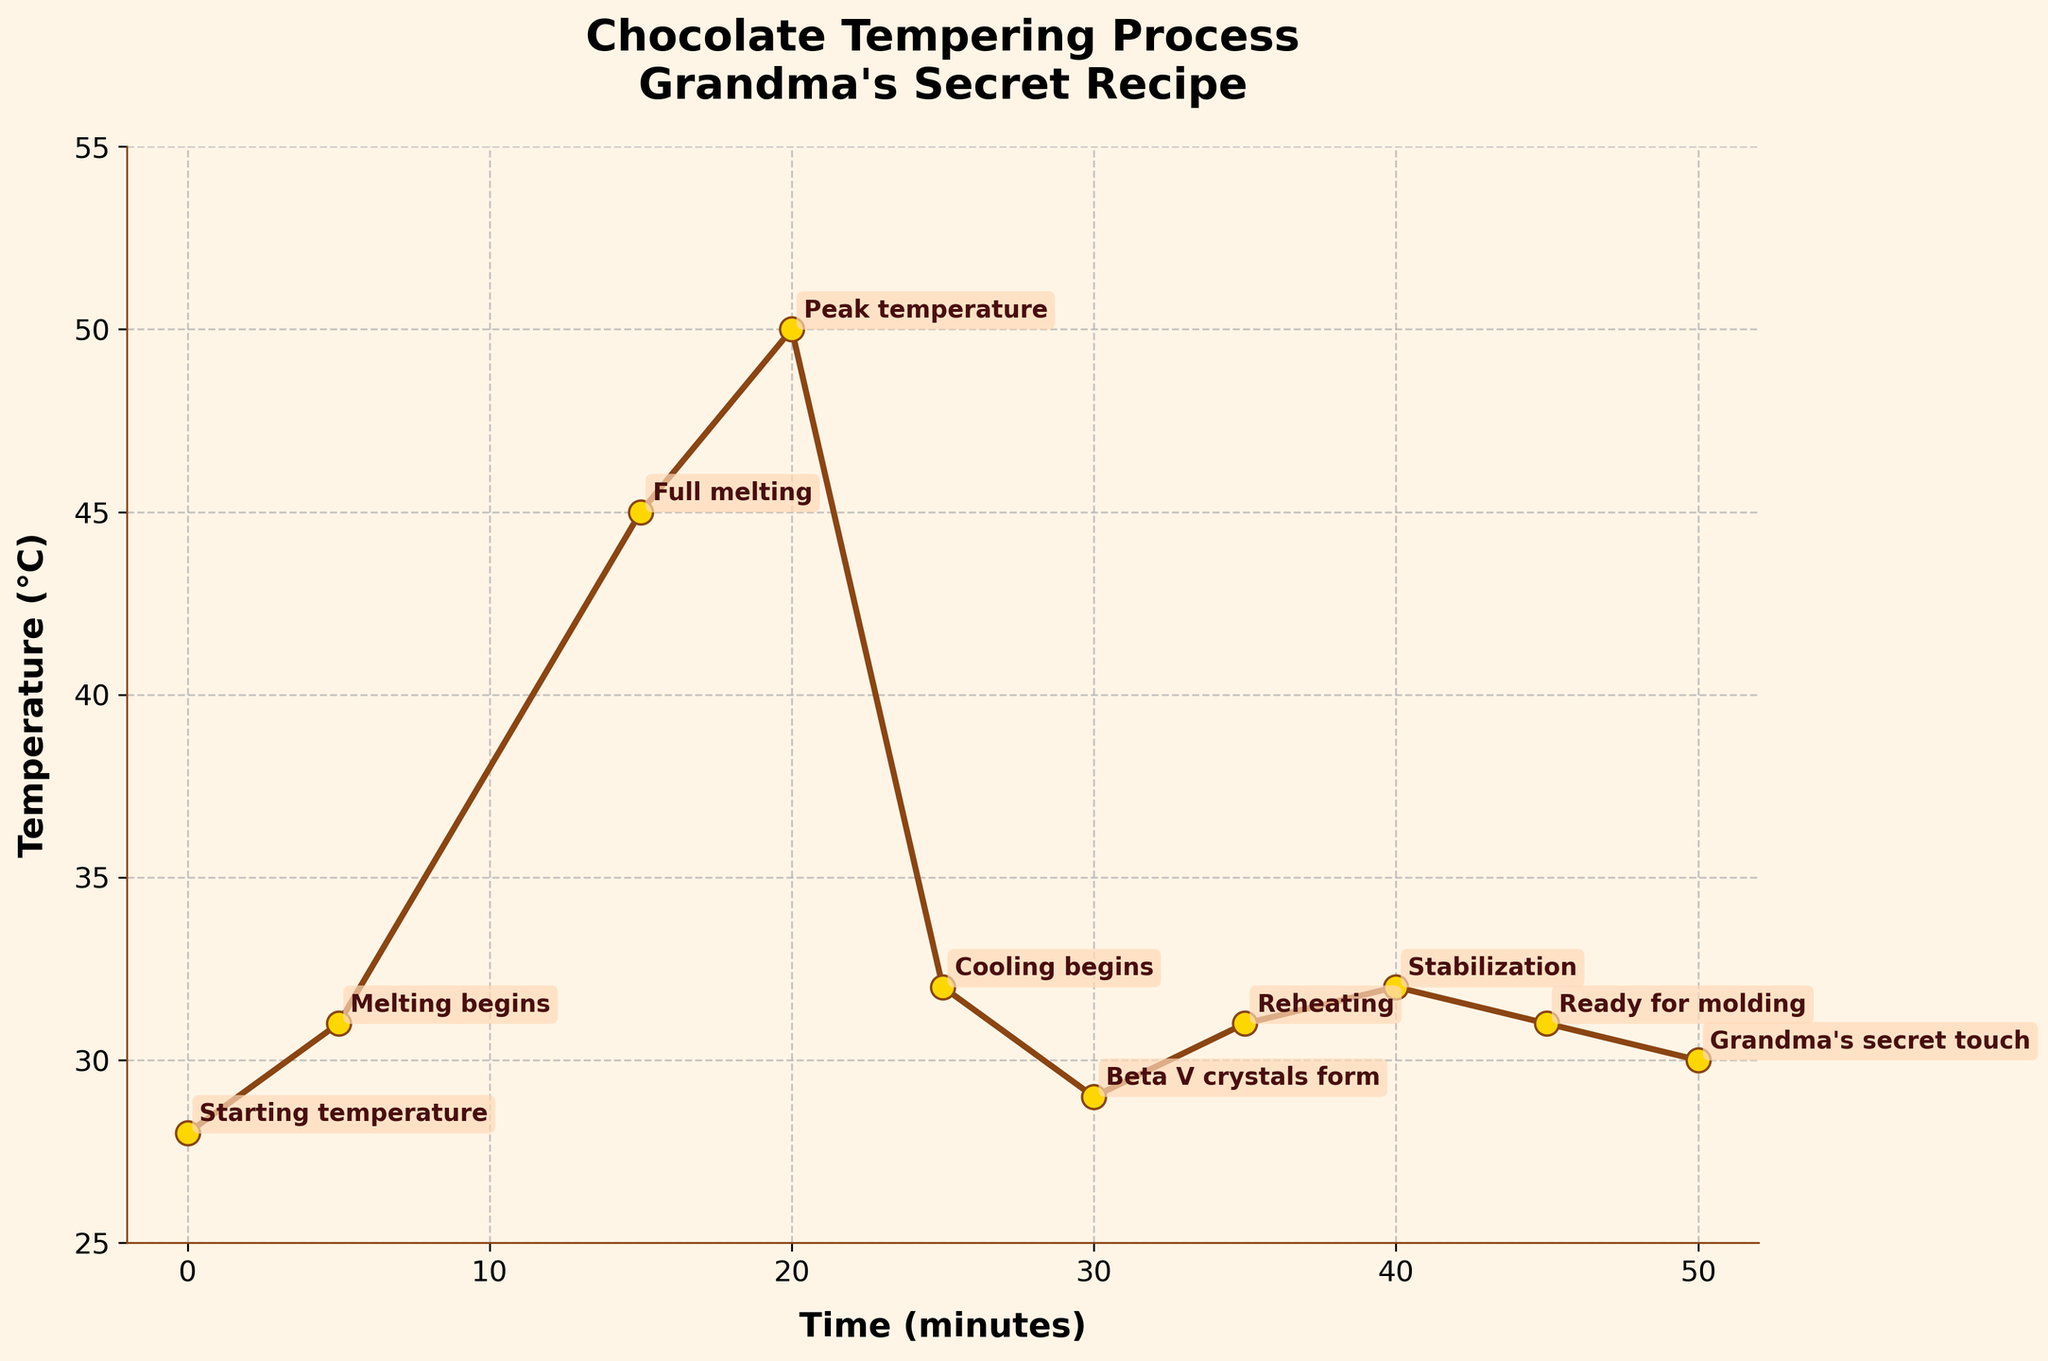what is the highest temperature reached during the chocolate tempering process? The highest temperature can be identified by looking for the maximum value on the y-axis of the chart, which is at 50°C.
Answer: 50°C What is the temperature difference between the "Full melting" and "Beta V crystals form" stages? Locate the temperatures at the "Full melting" (45°C) and "Beta V crystals form" (29°C) stages on the chart, then subtract 29°C from 45°C.
Answer: 16°C At what time does reheating occur and what is the corresponding temperature? Find the "Reheating" stage label on the chart, then locate the time on the x-axis and the corresponding temperature on the y-axis, which are at 35 minutes and 31°C.
Answer: 35 minutes, 31°C How does the temperature change from "Cooling begins" to "Beta V crystals form"? Look at the temperature at "Cooling begins" (32°C) and at "Beta V crystals form" (29°C). The temperature decreases by 3°C.
Answer: Decreases by 3°C Is the temperature during "Stabilization" higher than at "Grandma's secret touch"? Compare the temperatures at "Stabilization" (32°C) and "Grandma's secret touch" (30°C) stages. Since 32°C is greater than 30°C, the answer is yes.
Answer: Yes What is the average temperature between "Melting begins" and "Cooling begins"? Identify the temperatures at "Melting begins" (31°C), "Full melting" (45°C), "Peak temperature" (50°C), and "Cooling begins" (32°C). Sum these temperatures and divide by the number of stages (4). (31 + 45 + 50 + 32)/4 = 39.5°C.
Answer: 39.5°C Which stage has the lowest temperature and what is the value? Identify the lowest point on the y-axis which corresponds to 28°C at the "Starting temperature" stage.
Answer: Starting temperature, 28°C Compare the temperature trend between "Cooling begins" and "Ready for molding". Does it show an overall increase, decrease, or consistent temperature? Look at the temperatures from "Cooling begins" (32°C) to "Ready for molding" (31°C). The temperature initially decreases but then slightly increases at the end, giving an overall slight decrease trend.
Answer: Slight decrease 